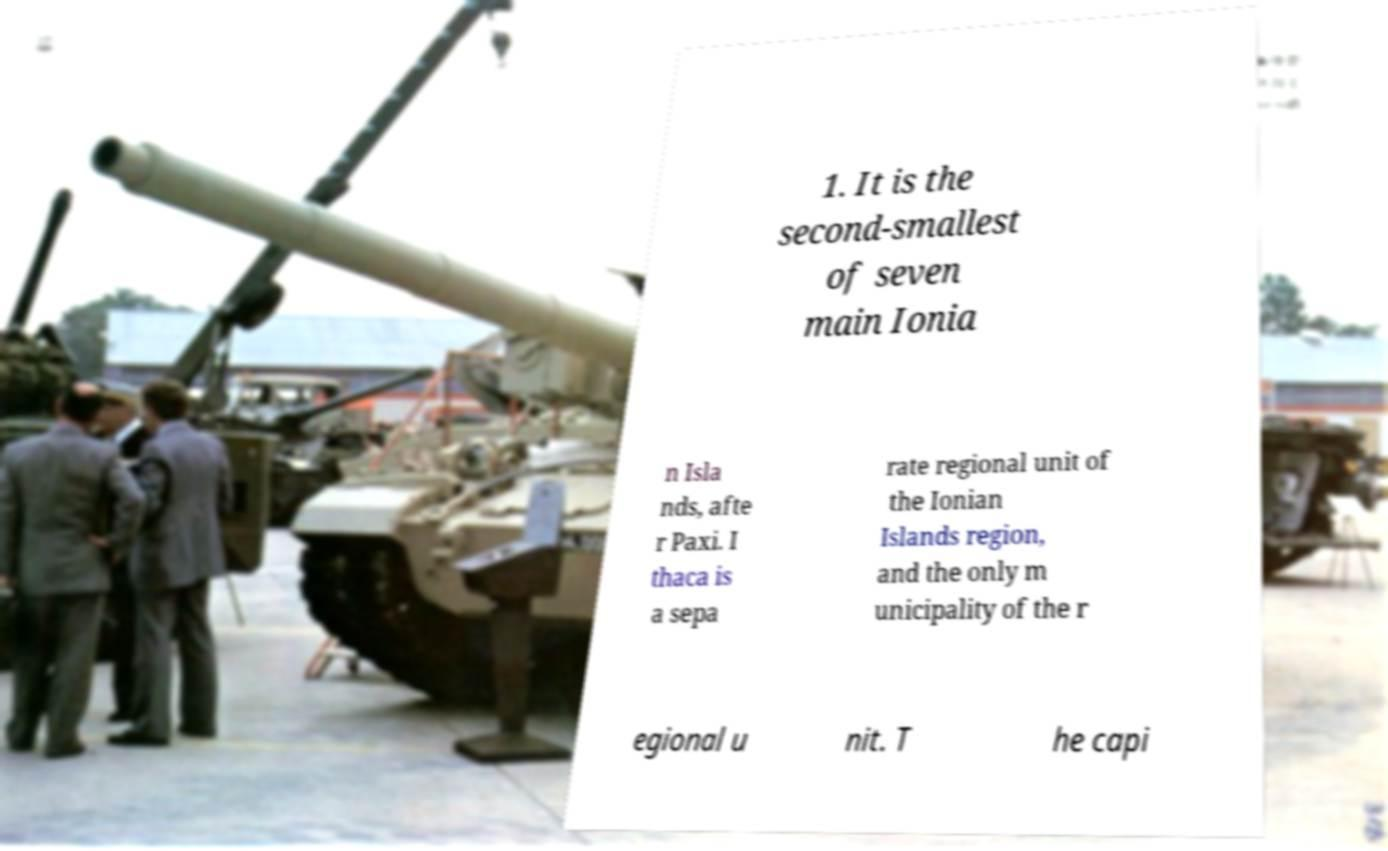Could you extract and type out the text from this image? 1. It is the second-smallest of seven main Ionia n Isla nds, afte r Paxi. I thaca is a sepa rate regional unit of the Ionian Islands region, and the only m unicipality of the r egional u nit. T he capi 